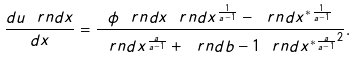<formula> <loc_0><loc_0><loc_500><loc_500>\frac { d u \ r n d { x } } { d x } = \frac { \phi \ r n d { x } \ r n d { x ^ { \frac { 1 } { a - 1 } } - \ r n d { x ^ { \ast } } ^ { \frac { 1 } { a - 1 } } } } { \ r n d { x ^ { \frac { a } { a - 1 } } + \ r n d { b - 1 } \ r n d { x ^ { \ast } } ^ { \frac { a } { a - 1 } } } ^ { 2 } } .</formula> 